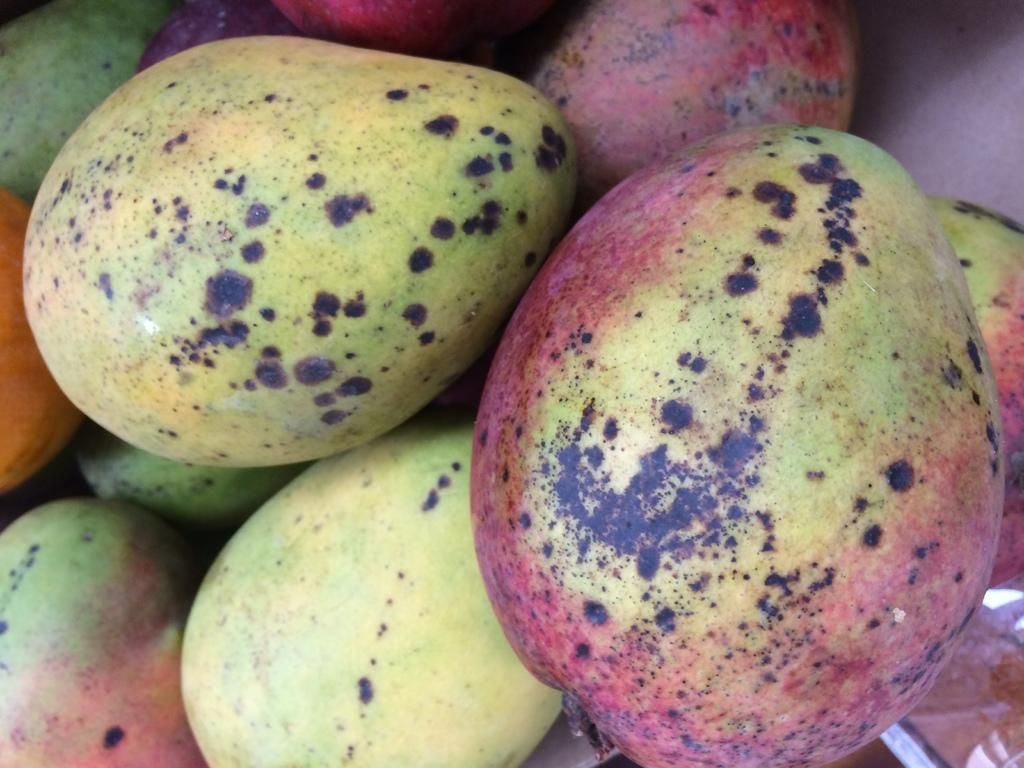What type of fruit is present in the image? There are mangoes in the image. What type of birds can be seen perched on the lamp in the image? There is no lamp or birds present in the image; it only features mangoes. 